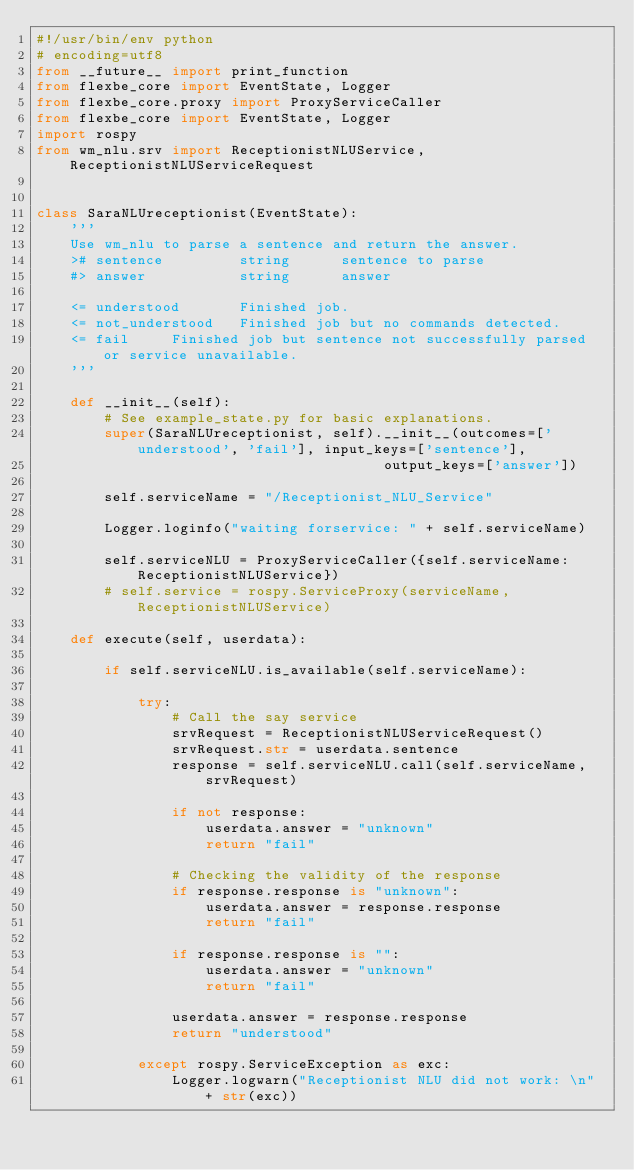<code> <loc_0><loc_0><loc_500><loc_500><_Python_>#!/usr/bin/env python
# encoding=utf8
from __future__ import print_function
from flexbe_core import EventState, Logger
from flexbe_core.proxy import ProxyServiceCaller
from flexbe_core import EventState, Logger
import rospy
from wm_nlu.srv import ReceptionistNLUService, ReceptionistNLUServiceRequest


class SaraNLUreceptionist(EventState):
    '''
    Use wm_nlu to parse a sentence and return the answer.
    ># sentence         string      sentence to parse
    #> answer           string      answer

    <= understood       Finished job.
    <= not_understood   Finished job but no commands detected.
    <= fail     Finished job but sentence not successfully parsed or service unavailable.
    '''

    def __init__(self):
        # See example_state.py for basic explanations.
        super(SaraNLUreceptionist, self).__init__(outcomes=['understood', 'fail'], input_keys=['sentence'],
                                         output_keys=['answer'])

        self.serviceName = "/Receptionist_NLU_Service"

        Logger.loginfo("waiting forservice: " + self.serviceName)

        self.serviceNLU = ProxyServiceCaller({self.serviceName: ReceptionistNLUService})
        # self.service = rospy.ServiceProxy(serviceName, ReceptionistNLUService)

    def execute(self, userdata):

        if self.serviceNLU.is_available(self.serviceName):

            try:
                # Call the say service
                srvRequest = ReceptionistNLUServiceRequest()
                srvRequest.str = userdata.sentence
                response = self.serviceNLU.call(self.serviceName, srvRequest)

                if not response:
                    userdata.answer = "unknown"
                    return "fail"

                # Checking the validity of the response
                if response.response is "unknown":
                    userdata.answer = response.response
                    return "fail"

                if response.response is "":
                    userdata.answer = "unknown"
                    return "fail"

                userdata.answer = response.response
                return "understood"

            except rospy.ServiceException as exc:
                Logger.logwarn("Receptionist NLU did not work: \n" + str(exc))
</code> 